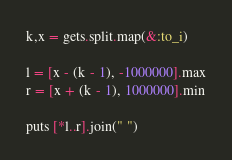<code> <loc_0><loc_0><loc_500><loc_500><_Ruby_>k,x = gets.split.map(&:to_i)

l = [x - (k - 1), -1000000].max
r = [x + (k - 1), 1000000].min

puts [*l..r].join(" ")
</code> 